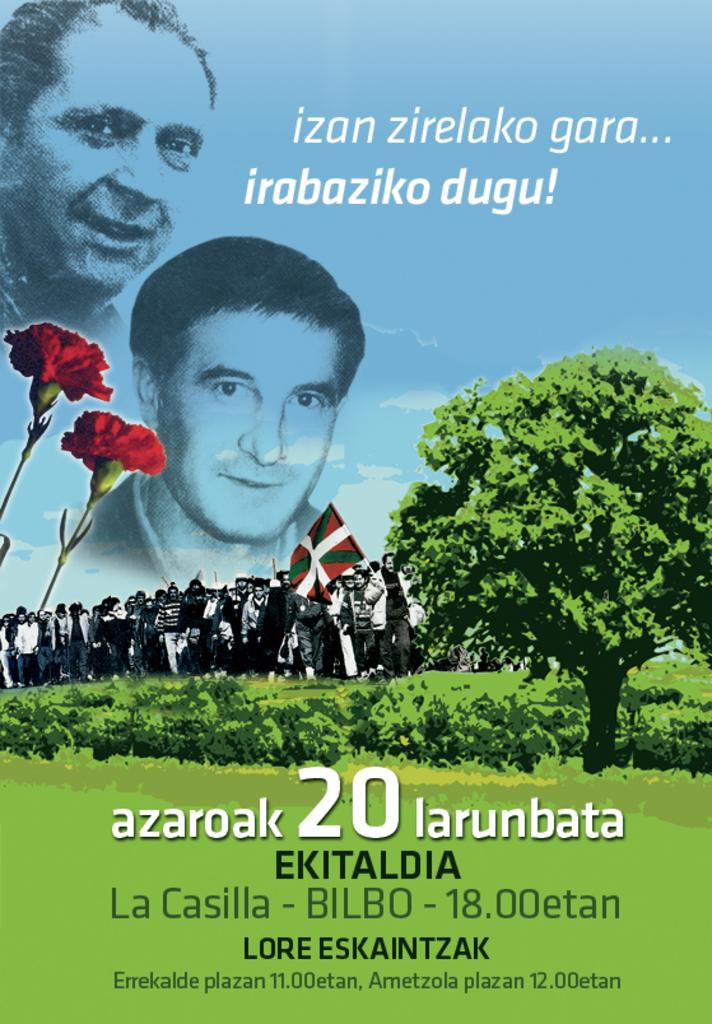<image>
Write a terse but informative summary of the picture. A poster showing two faces, and the number 20 in large digits. 